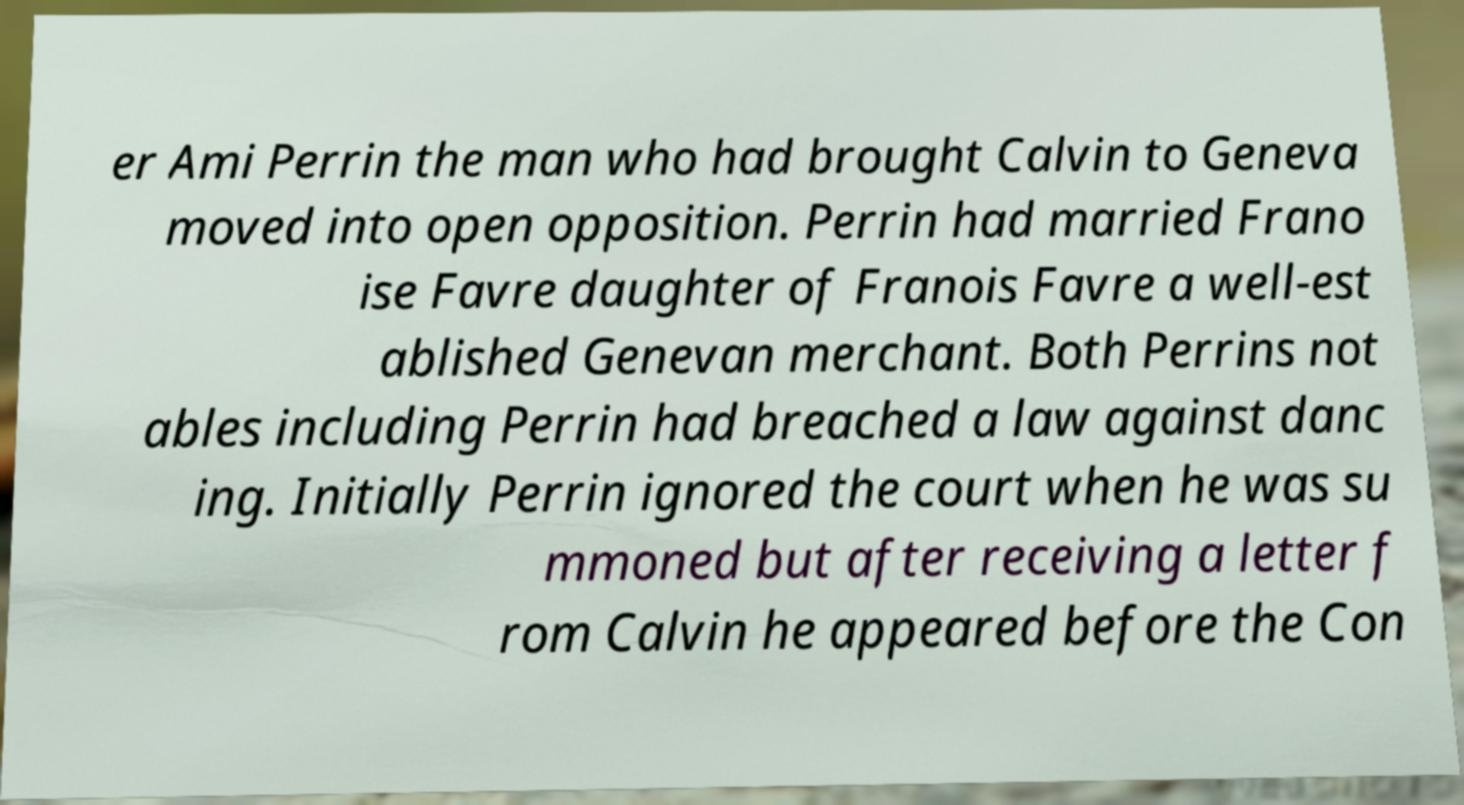For documentation purposes, I need the text within this image transcribed. Could you provide that? er Ami Perrin the man who had brought Calvin to Geneva moved into open opposition. Perrin had married Frano ise Favre daughter of Franois Favre a well-est ablished Genevan merchant. Both Perrins not ables including Perrin had breached a law against danc ing. Initially Perrin ignored the court when he was su mmoned but after receiving a letter f rom Calvin he appeared before the Con 